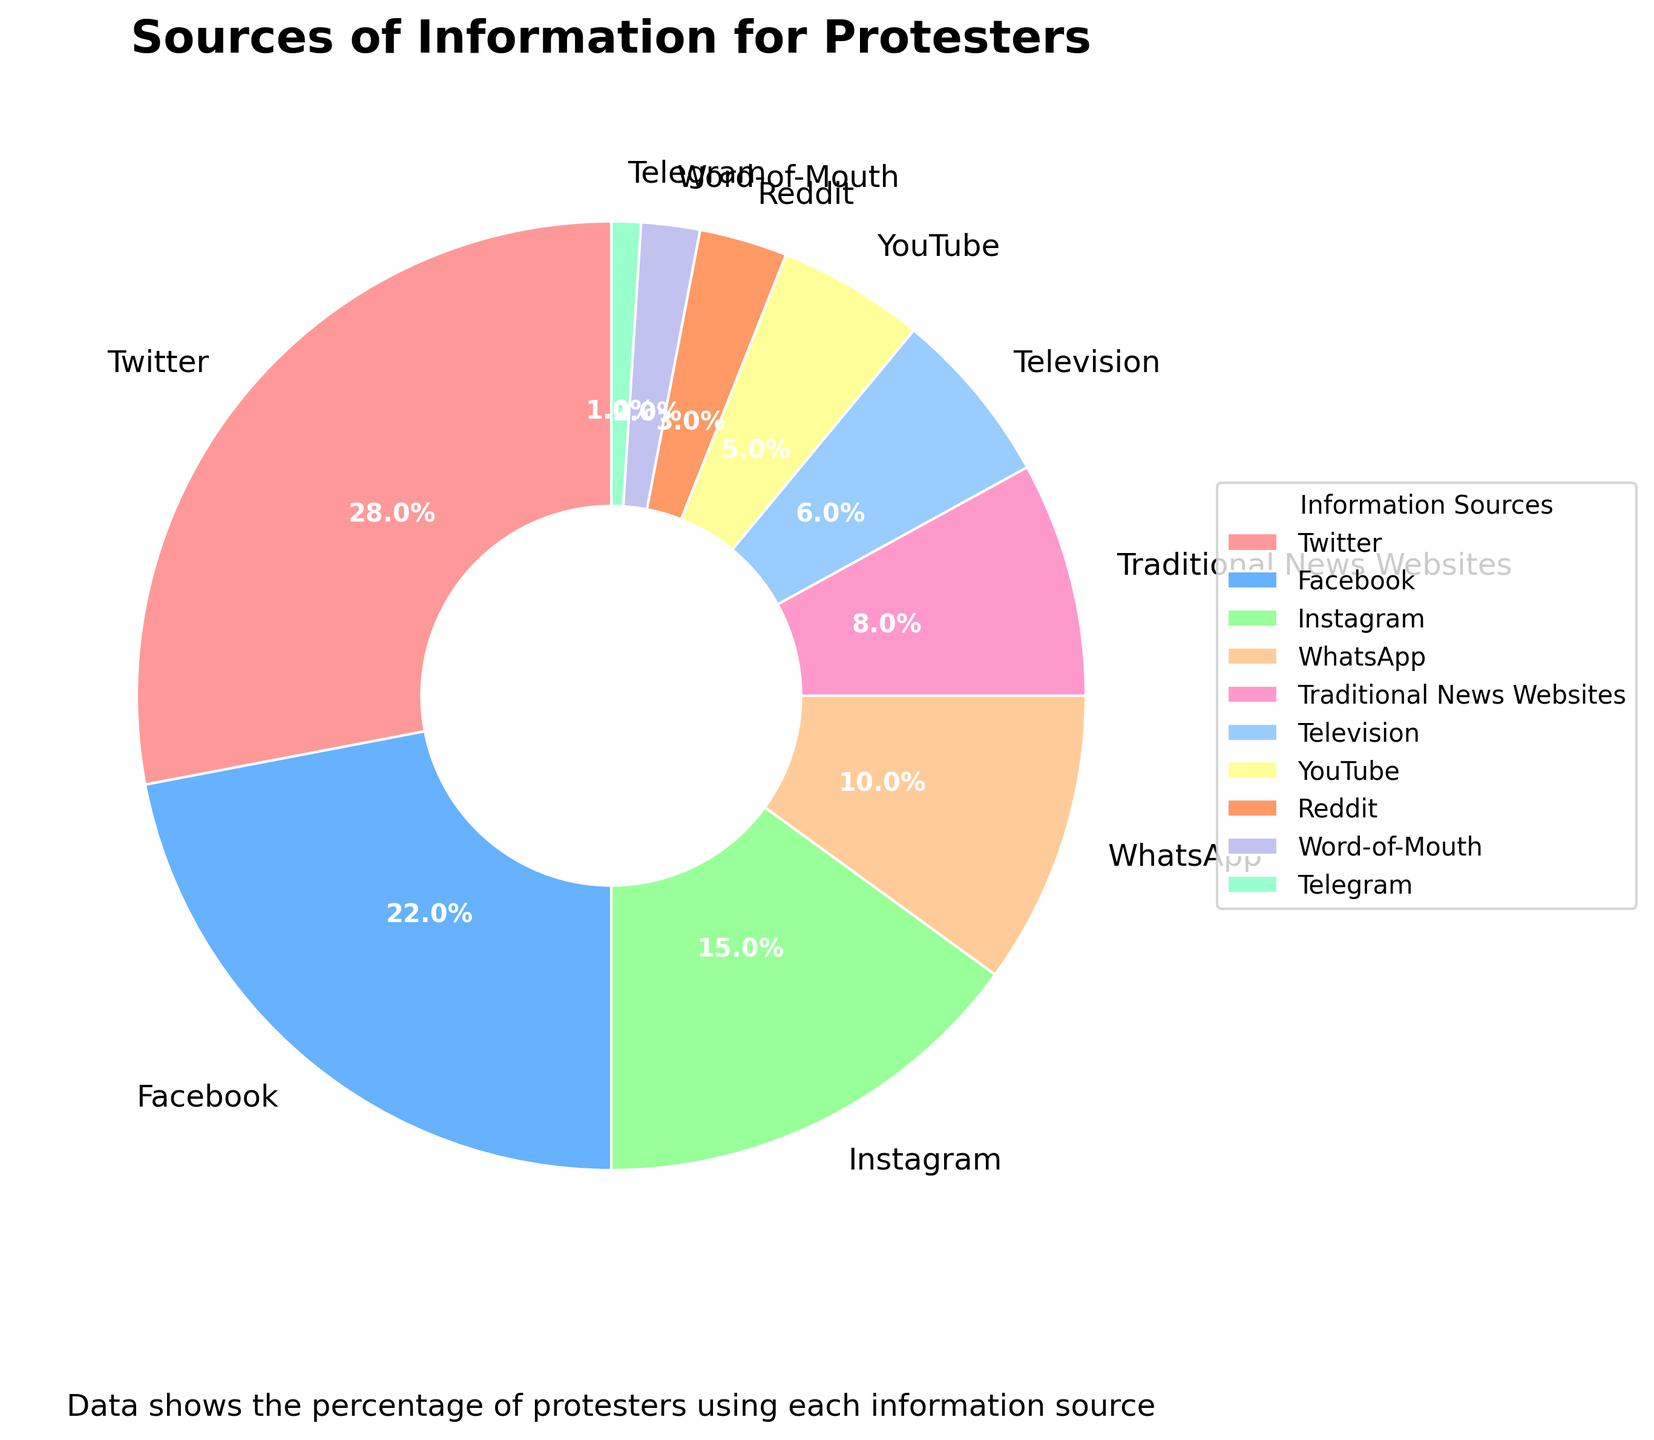Which information source is the most used by protesters? The wedge labeled "Twitter" occupies the largest segment of the pie chart with 28%, indicating that it is the most used source.
Answer: Twitter Which social media platform has the second highest usage? The wedge labeled "Facebook" is the second-largest with 22%, making Facebook the second most used social media platform.
Answer: Facebook What percentage of information do protesters gather from traditional media (Television and Traditional News Websites combined)? Combine the percentages for Television and Traditional News Websites: 6% (Television) + 8% (Traditional News Websites) = 14%.
Answer: 14% How does the usage of Instagram compare to that of WhatsApp among protesters? The pie chart shows that Instagram has 15% usage while WhatsApp has 10%, meaning Instagram is used more than WhatsApp.
Answer: Instagram is used more than WhatsApp Which source of information is the least used by protesters? The smallest wedge in the pie chart is labeled "Telegram" with 1%, indicating it is the least used source.
Answer: Telegram Is traditional media more used than word-of-mouth? The pie chart shows that traditional media (Television: 6% + Traditional News Websites: 8% = 14%) has a higher combined percentage than word-of-mouth (2%).
Answer: Yes Visualize the usage of WhatsApp, Traditional News Websites, and Television combined. How does it compare to the usage of Twitter? The combined usage of WhatsApp, Traditional News Websites, and Television is 10% + 8% + 6% = 24%, which is less than the usage of Twitter which is 28%.
Answer: Less than Twitter What is the cumulative percentage of the least used four sources of information? Sum the percentages of the smallest segments: YouTube (5%), Reddit (3%), Word-of-Mouth (2%), Telegram (1%) = 5% + 3% + 2% + 1% = 11%.
Answer: 11% 